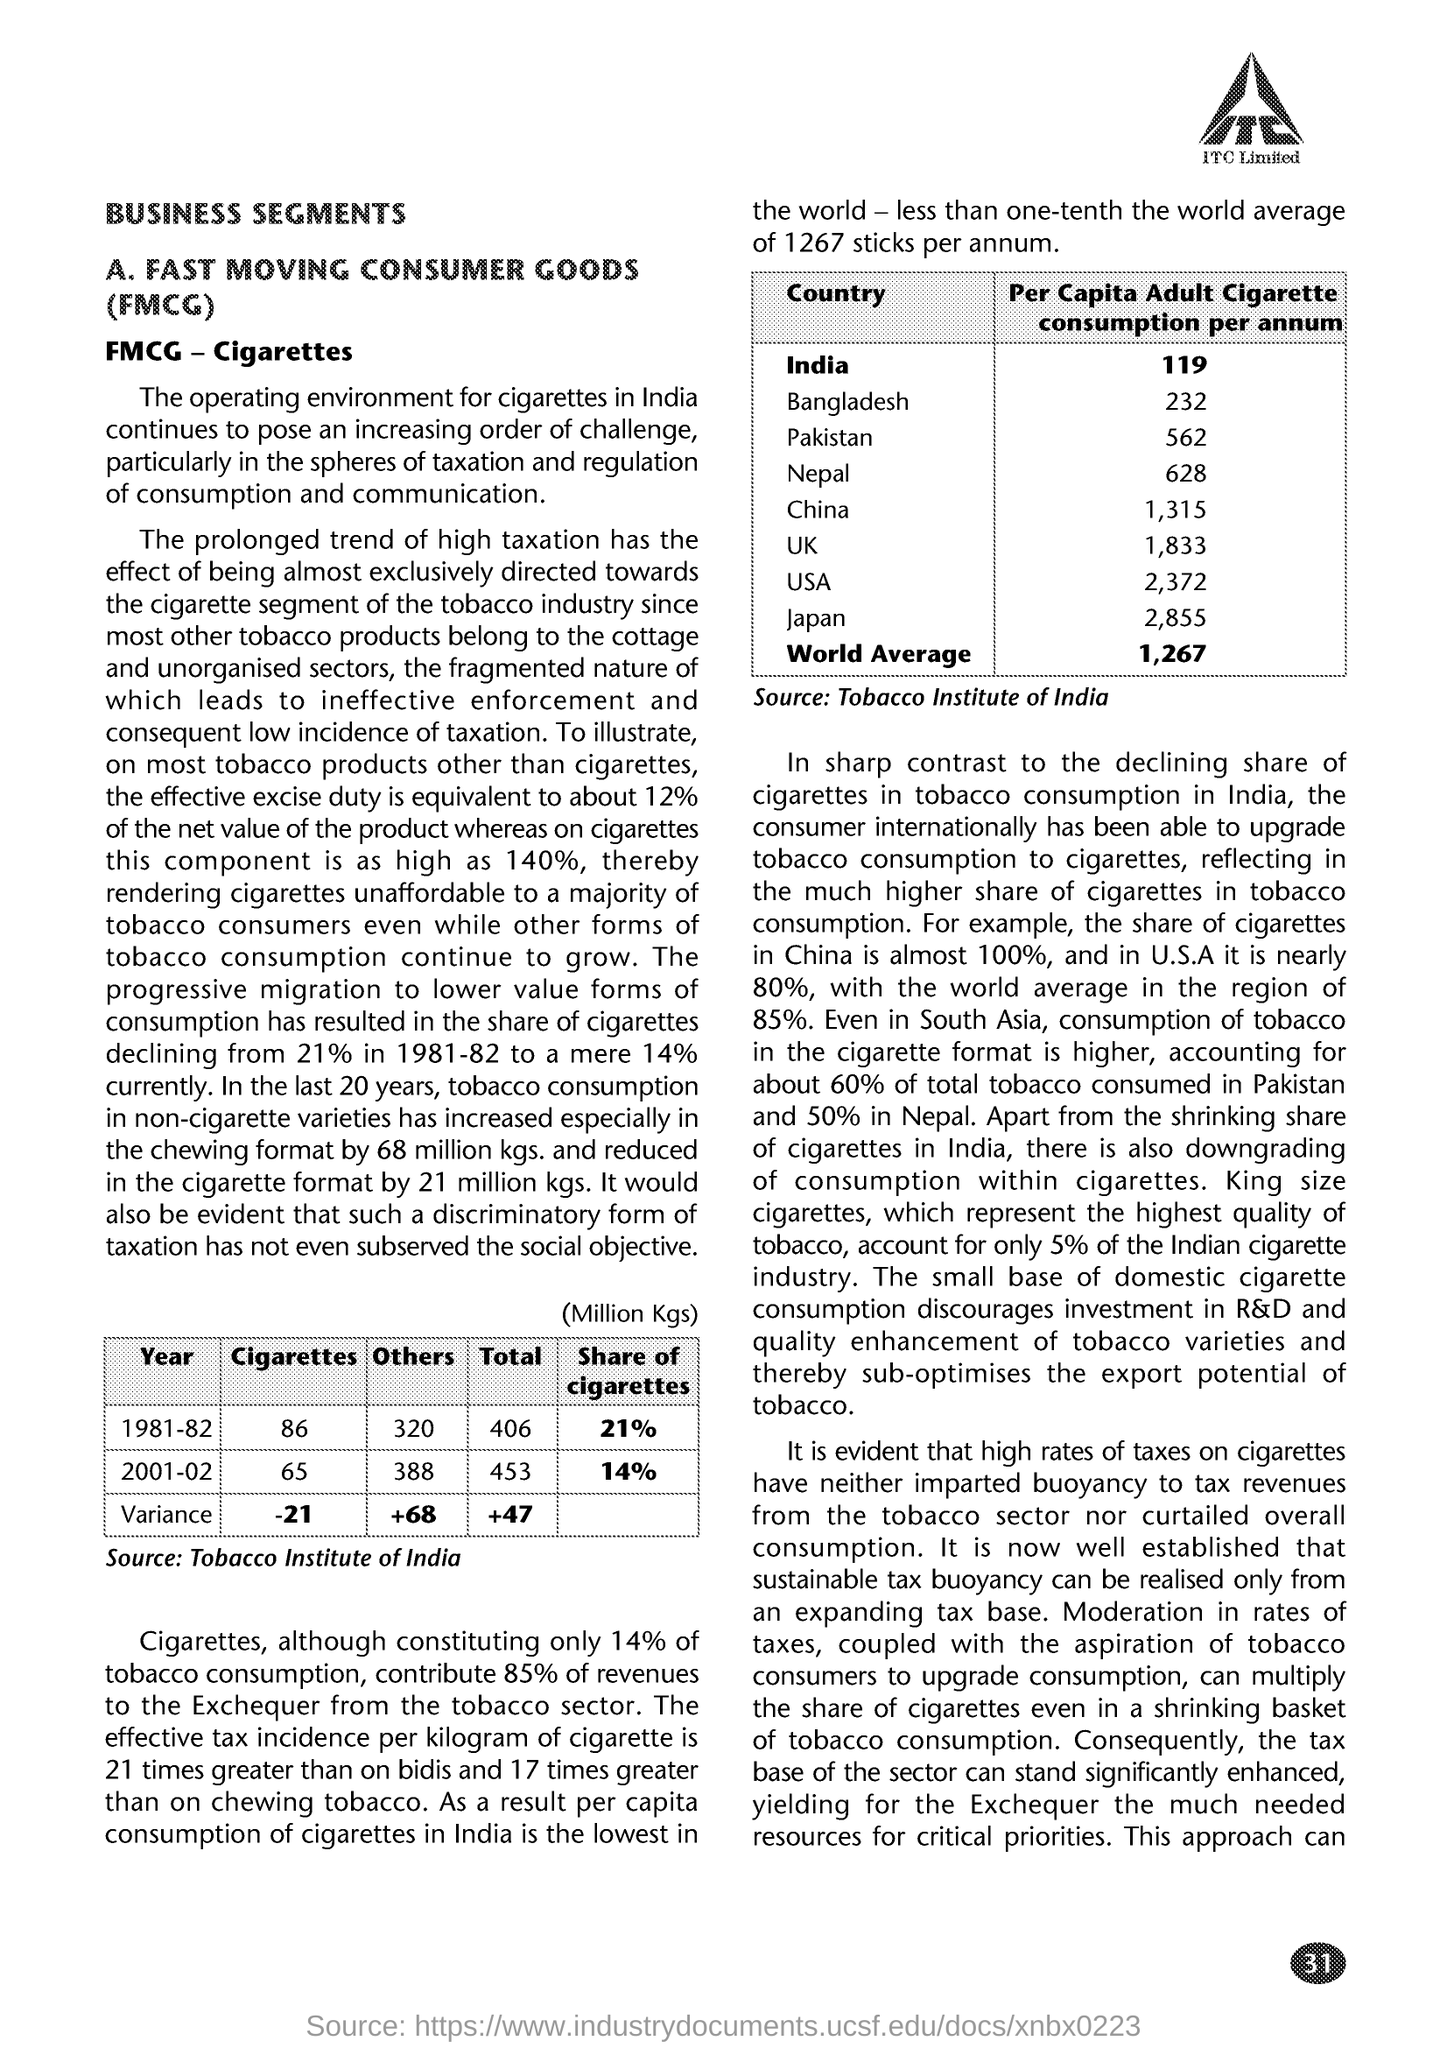Point out several critical features in this image. The average per capita adult cigarette consumption globally is approximately 1,267 cigarettes per year. The main heading of the document is "Business Segments. The average annual cigarette consumption per adult in the United States is estimated to be approximately 2,372 cigarettes per person. In 1981-82, cigarettes accounted for 21% of the total revenue generated by the Indian cigarette industry. Fast Moving Consumer Goods (FMCG) refers to a broad category of everyday items that are typically sold quickly and in large quantities, such as food products, household items, and personal care products. 